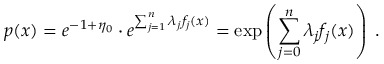<formula> <loc_0><loc_0><loc_500><loc_500>p ( x ) = e ^ { - 1 + \eta _ { 0 } } \cdot e ^ { \sum _ { j = 1 } ^ { n } \lambda _ { j } f _ { j } ( x ) } = \exp \left ( \sum _ { j = 0 } ^ { n } \lambda _ { j } f _ { j } ( x ) \right ) \, .</formula> 